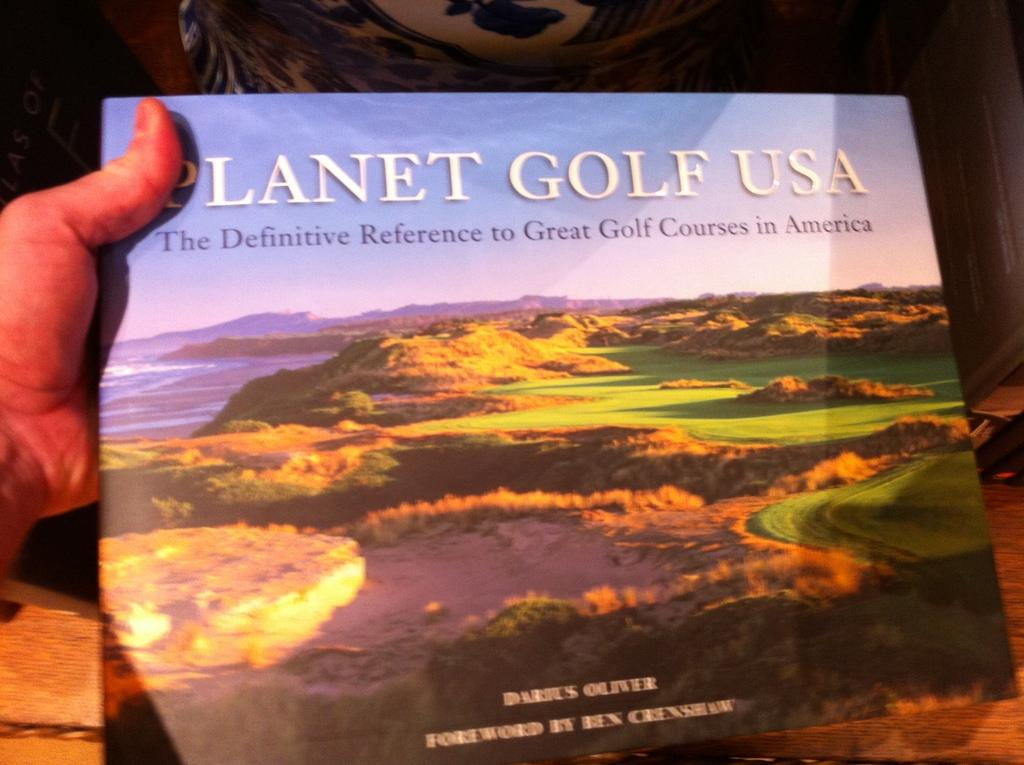<image>
Share a concise interpretation of the image provided. The book about golfing is called Planet Golf USA 